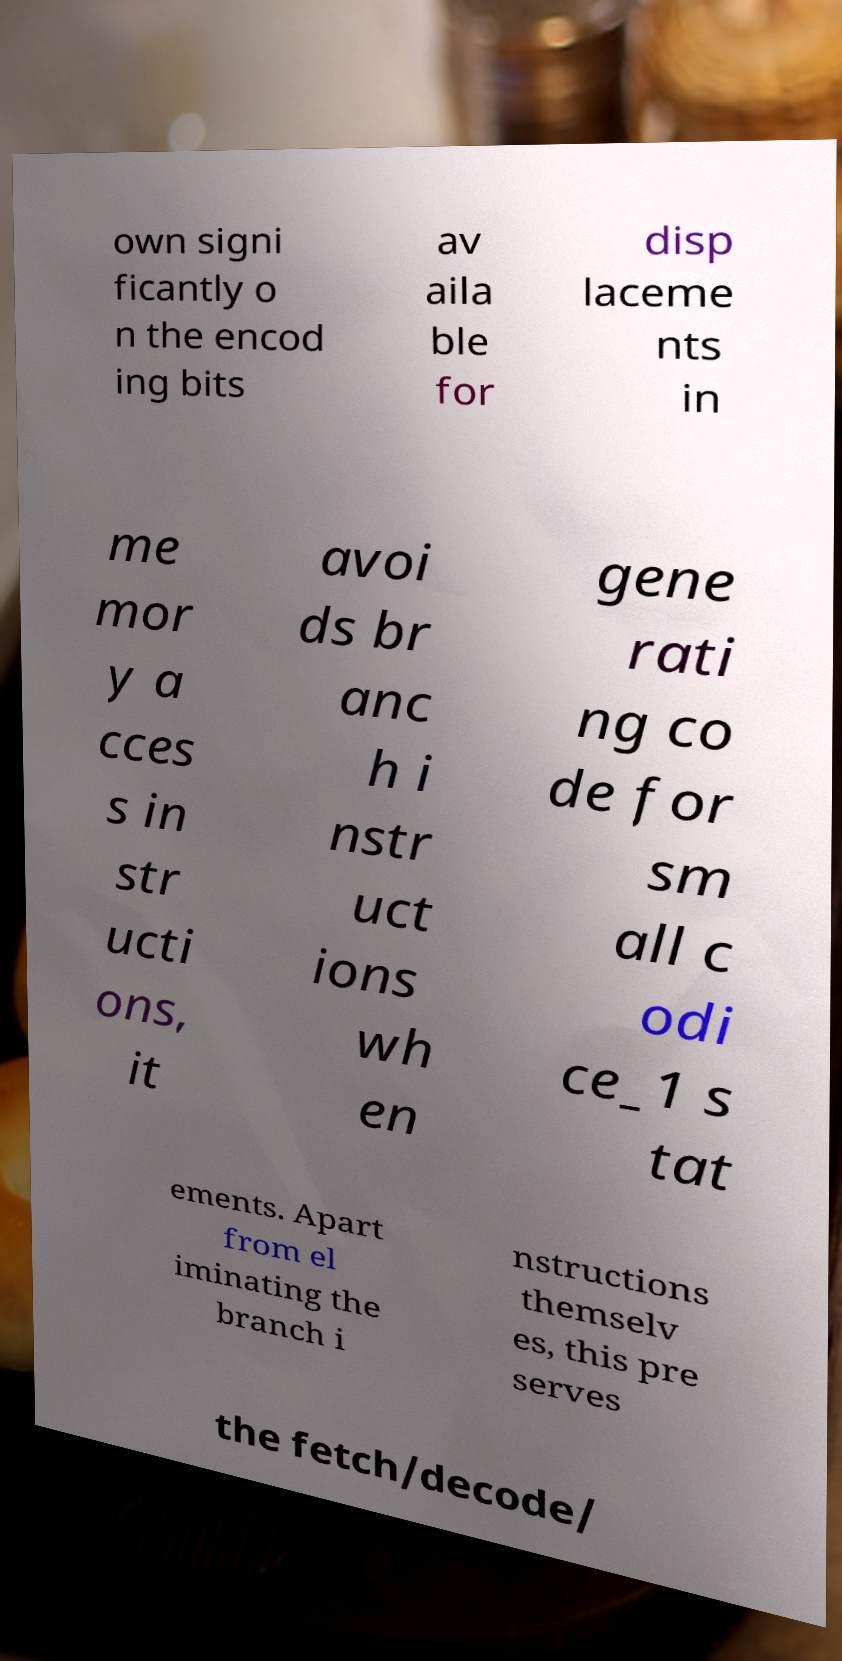I need the written content from this picture converted into text. Can you do that? own signi ficantly o n the encod ing bits av aila ble for disp laceme nts in me mor y a cces s in str ucti ons, it avoi ds br anc h i nstr uct ions wh en gene rati ng co de for sm all c odi ce_1 s tat ements. Apart from el iminating the branch i nstructions themselv es, this pre serves the fetch/decode/ 